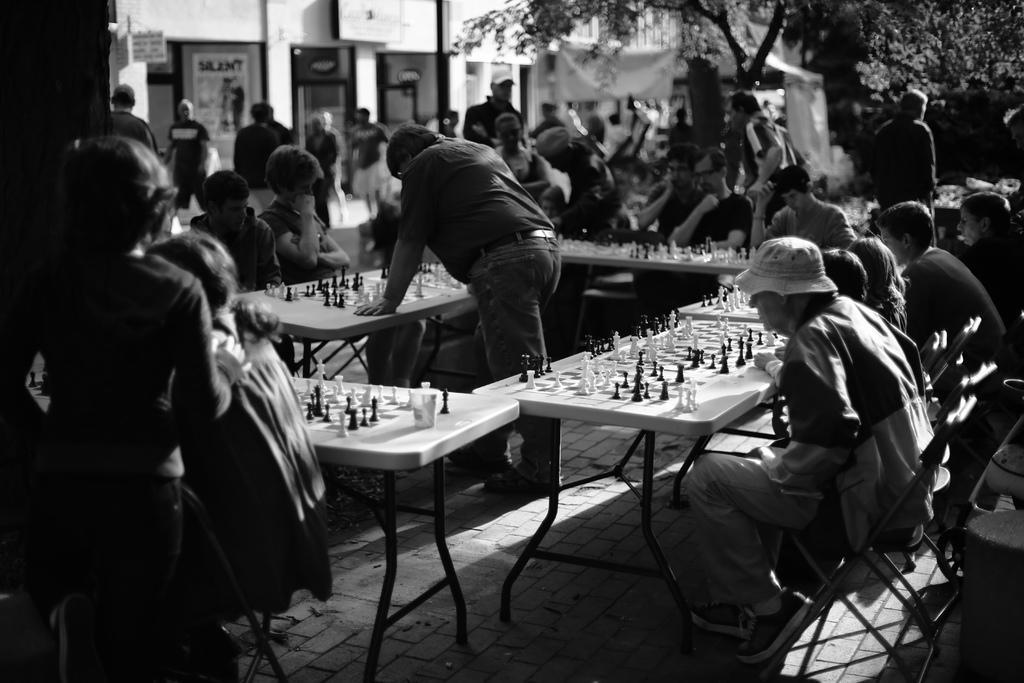In one or two sentences, can you explain what this image depicts? In the foreground of this image, where we can see persons sitting around the tables on which there are chess boards and chess coins on it. In the middle, there is a man standing. In the background, there are persons, buildings, trees and on the bottom, there are chairs and the pavement. 